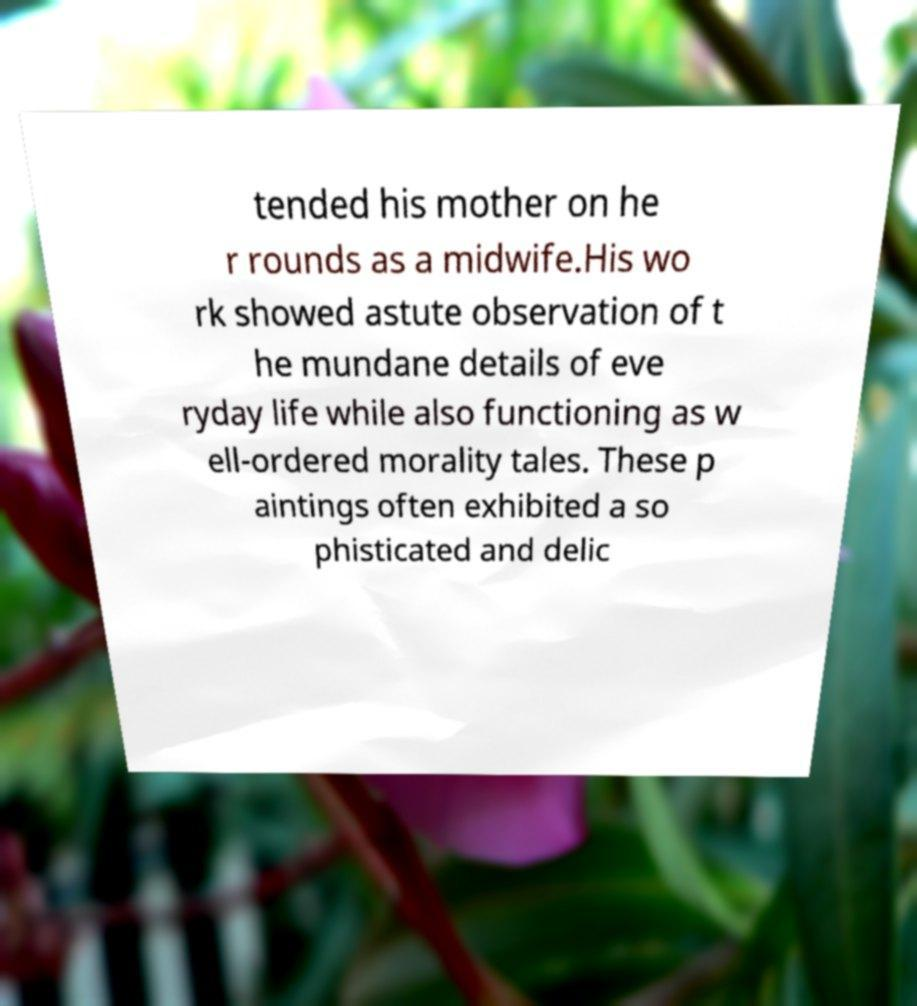Please read and relay the text visible in this image. What does it say? tended his mother on he r rounds as a midwife.His wo rk showed astute observation of t he mundane details of eve ryday life while also functioning as w ell-ordered morality tales. These p aintings often exhibited a so phisticated and delic 